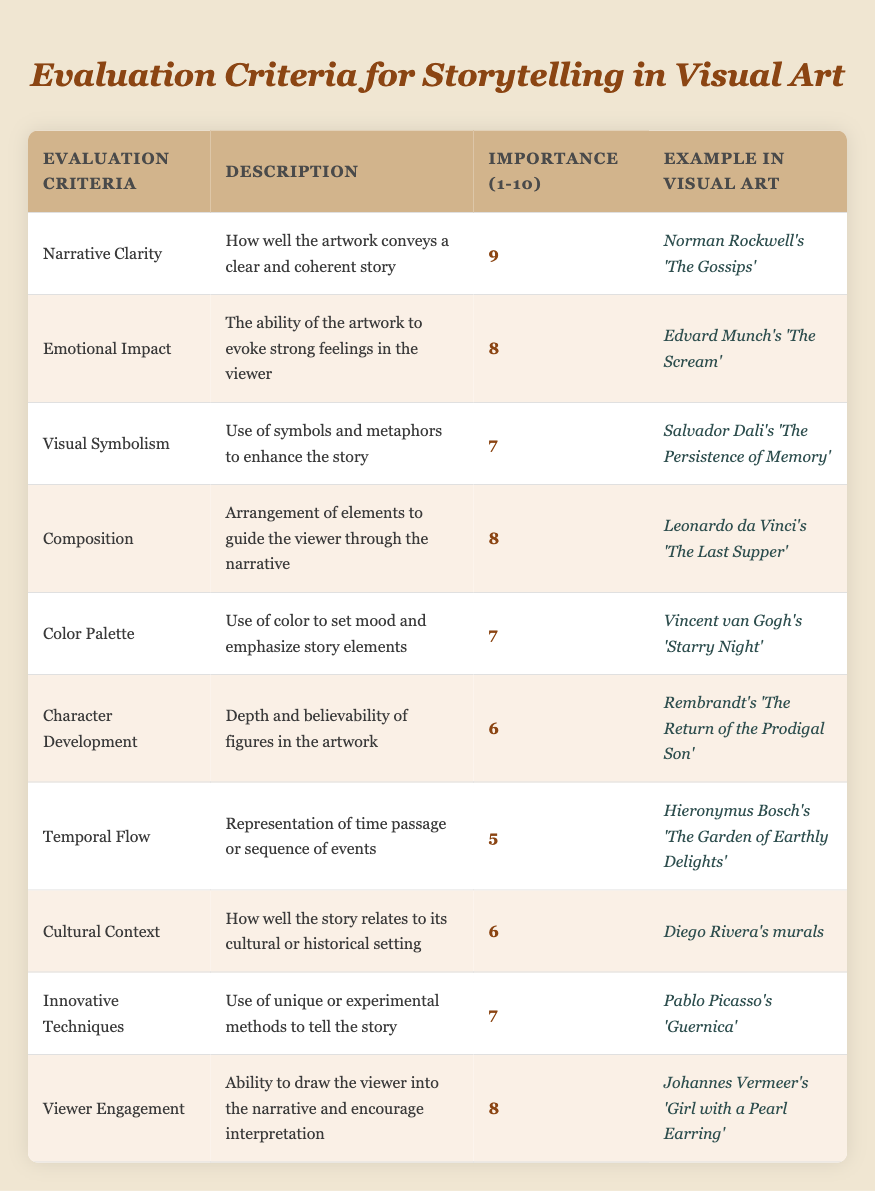What is the highest importance rating among the evaluation criteria? The highest importance rating can be found by scanning the "Importance (1-10)" column for the maximum value. From the table, the criteria with the highest rating is "Narrative Clarity" with a rating of 9.
Answer: 9 Which artwork is an example of "Viewer Engagement"? To find the artwork associated with "Viewer Engagement", look for this criteria in the "Evaluation Criteria" column. It is linked to "Johannes Vermeer's 'Girl with a Pearl Earring'".
Answer: Johannes Vermeer's 'Girl with a Pearl Earring' Are there any evaluation criteria with a rating of 5? By checking the "Importance (1-10)" column, one can see if any criteria have a rating of 5. The table shows "Temporal Flow" has this rating.
Answer: Yes What is the average importance rating of "Color Palette" and "Character Development"? First, find the importance ratings for both criteria: "Color Palette" has a rating of 7 and "Character Development" has a rating of 6. Sum them: 7 + 6 = 13, then divide by 2 (the number of criteria): 13 / 2 = 6.5.
Answer: 6.5 Which criteria have a higher importance rating, "Innovative Techniques" or "Visual Symbolism"? Look at the importance ratings for both: "Innovative Techniques" is rated 7 and "Visual Symbolism" is rated 7 as well; they are equal. Compare them directly to answer.
Answer: They are equal 